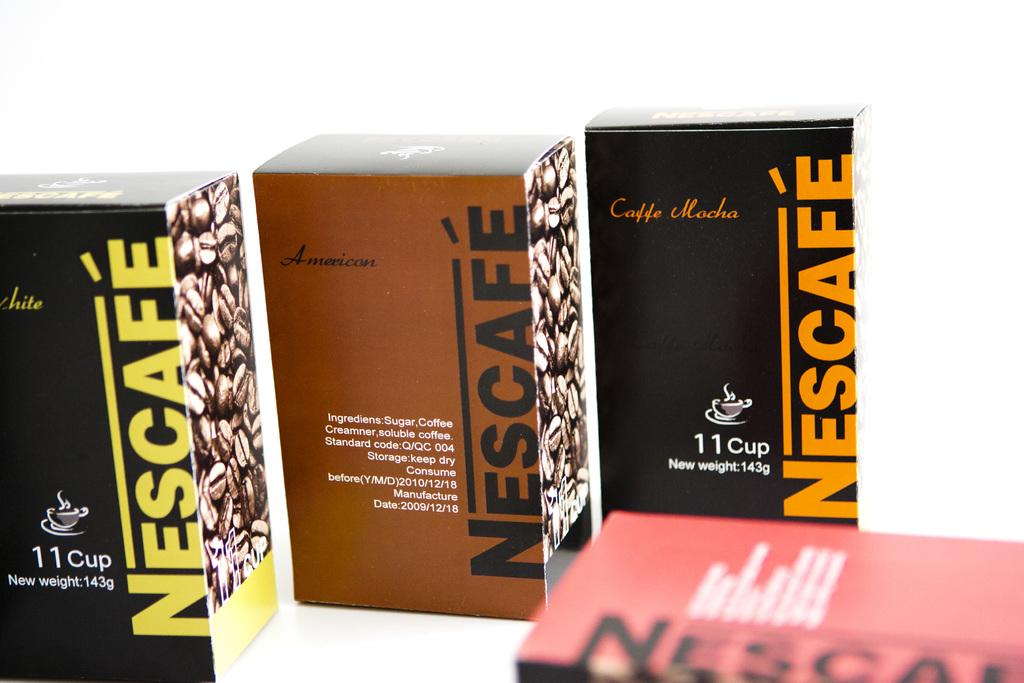Provide a one-sentence caption for the provided image. Several different flavors of Nescafe coffee are shown. 